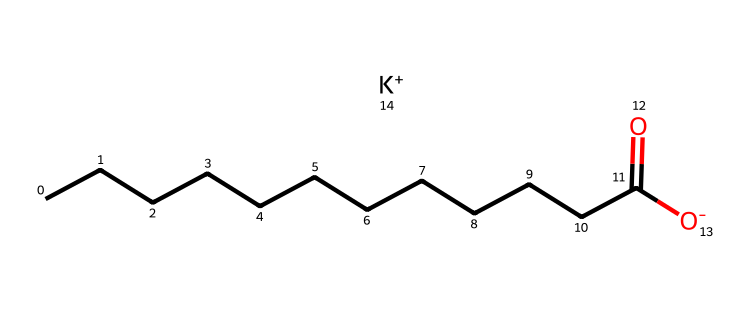how many carbon atoms are in potassium cocoate? The structure indicates a carbon chain made up of 12 carbon atoms, as inferred from the linear part of the molecule before the carboxylate group.
Answer: 12 what type of compound is potassium cocoate? This molecule is classified as a salt derived from a fatty acid (coconut fatty acid). The presence of a potassium cation and a conjugate base from the fatty acid confirms this.
Answer: salt what is the charge on the carboxylate group? The formula indicates that the carboxylic acid part has lost a hydrogen ion, resulting in a negative charge on the oxygen atom of the carboxylate group.
Answer: negative how many total oxygen atoms are in potassium cocoate? From the structure, there is one oxygen atom in the carboxylate group and another in the conjugate base, totaling two oxygen atoms.
Answer: 2 is potassium cocoate hydrophilic or hydrophobic? The presence of a long carbon chain indicates a hydrophobic nature due to the non-polar characteristics of the alkane part of the molecule, while the carboxylate group exhibits hydrophilic properties. However, the overall function as a detergent means it can effectively interact with both hydrophilic and hydrophobic substances.
Answer: amphiphilic how does the presence of potassium affect the properties of cocoate? Potassium ions can improve the solubility and stability of the soap in water compared to sodium, as potassium cocoate has a more soluble structure in some applications, enhancing its detergent properties.
Answer: solubility 